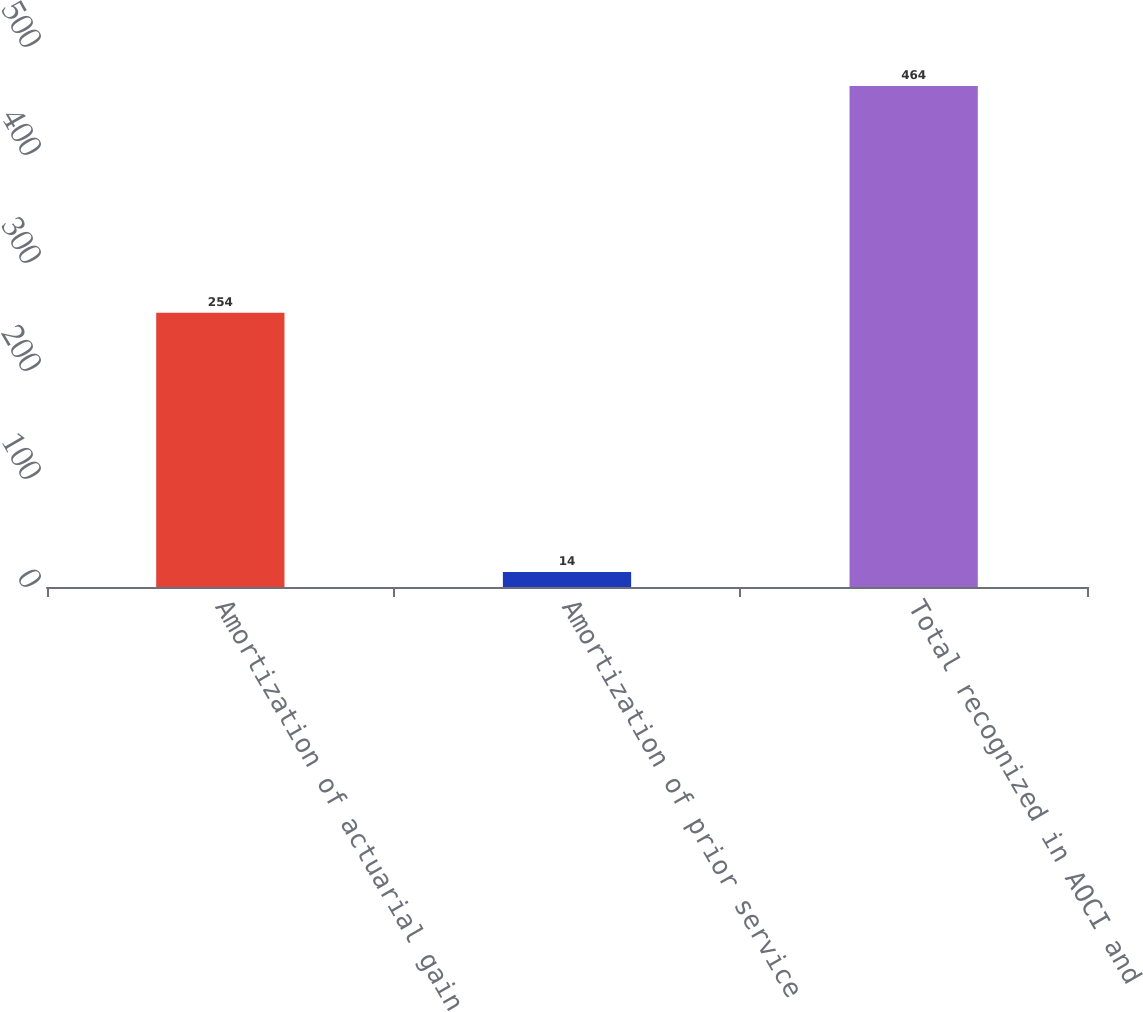Convert chart to OTSL. <chart><loc_0><loc_0><loc_500><loc_500><bar_chart><fcel>Amortization of actuarial gain<fcel>Amortization of prior service<fcel>Total recognized in AOCI and<nl><fcel>254<fcel>14<fcel>464<nl></chart> 